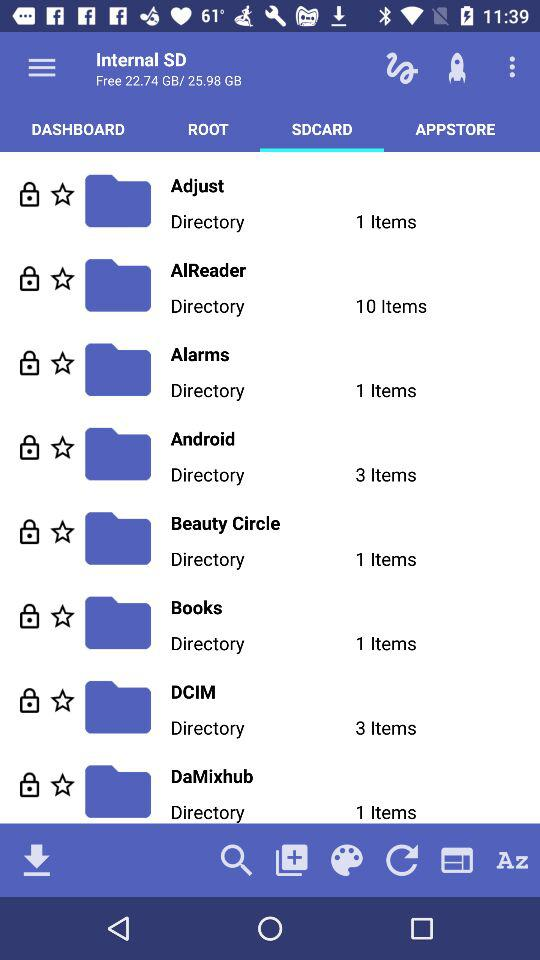How much free space is available on the SD card? The free space available is 22.74 GB or 25.98 GB. 